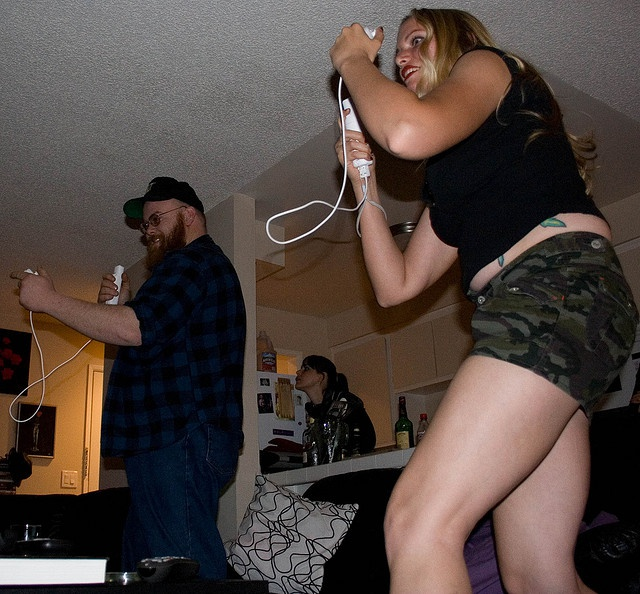Describe the objects in this image and their specific colors. I can see people in gray, black, tan, and darkgray tones, people in gray, black, brown, and maroon tones, couch in gray, black, and purple tones, couch in gray and black tones, and couch in gray, black, maroon, and brown tones in this image. 